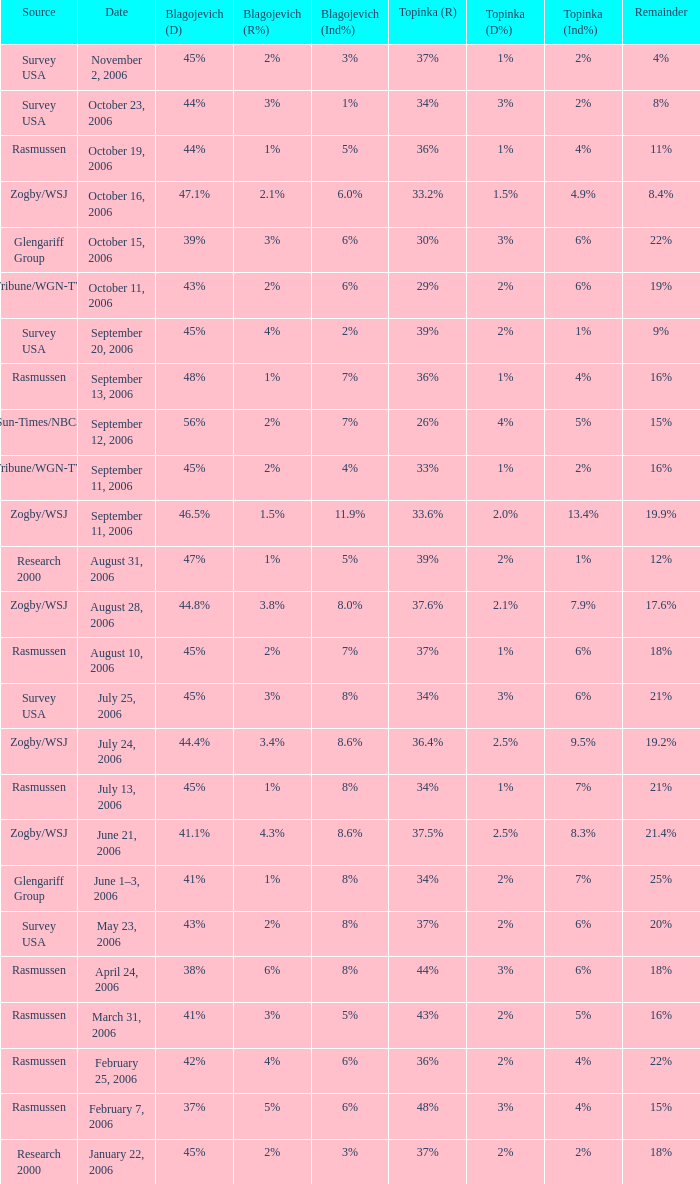Which Blagojevich (D) has a Source of zogby/wsj, and a Date of october 16, 2006? 47.1%. 